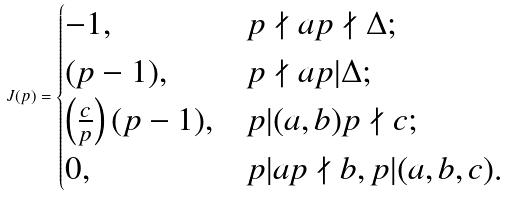Convert formula to latex. <formula><loc_0><loc_0><loc_500><loc_500>J ( p ) = \begin{cases} - 1 , & p \nmid a p \nmid \Delta ; \\ ( p - 1 ) , & p \nmid a p | \Delta ; \\ \left ( \frac { c } { p } \right ) ( p - 1 ) , & p | ( a , b ) p \nmid c ; \\ 0 , & p | a p \nmid b , p | ( a , b , c ) . \end{cases}</formula> 